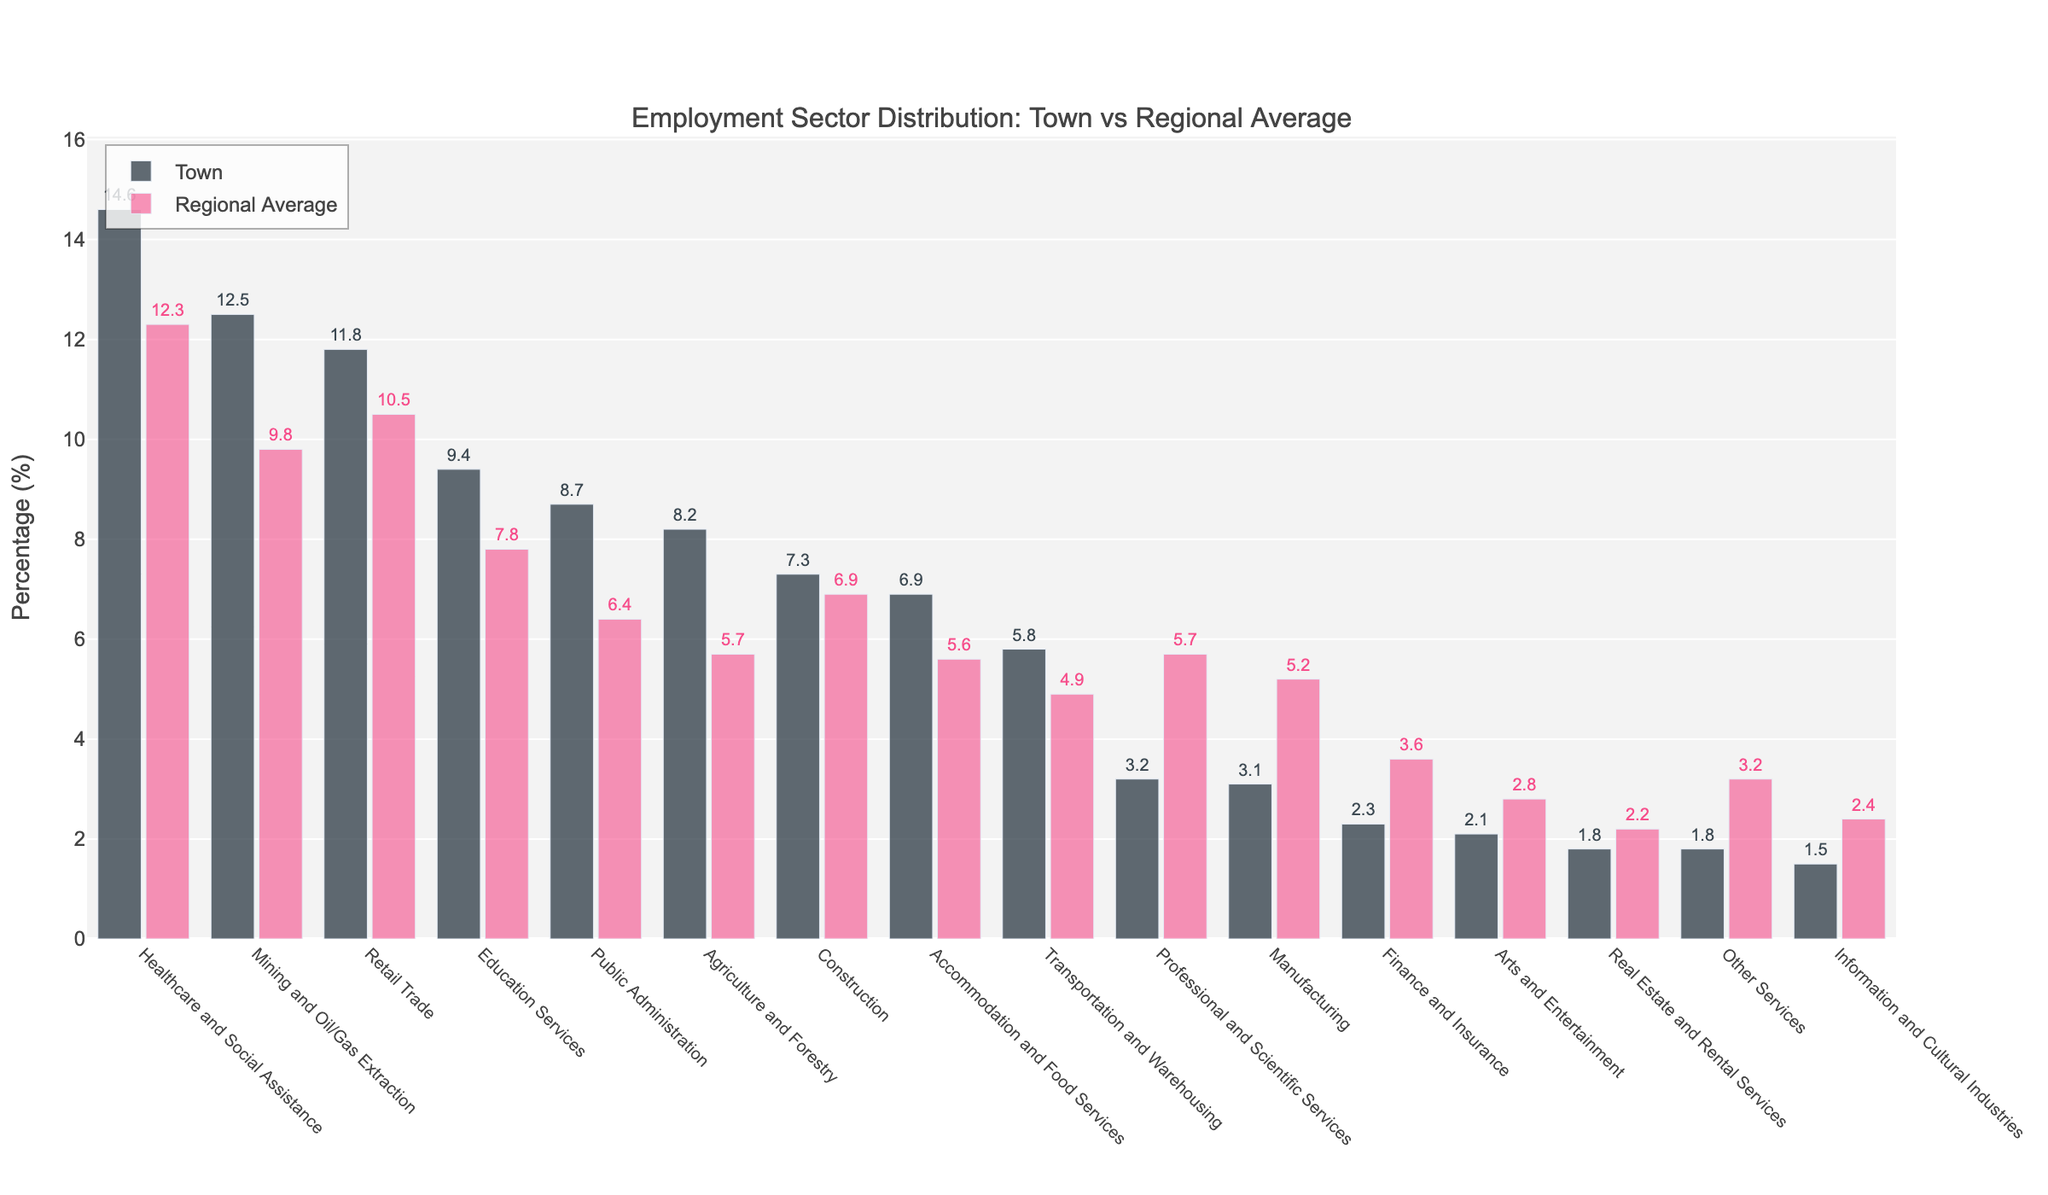How does the percentage of employment in Healthcare and Social Assistance compare between the town and the regional average? According to the figure, the bar representing Healthcare and Social Assistance is higher for the town than the regional average. Specifically, the town's percentage is 14.6% while the regional average is 12.3%. The town has a higher percentage in Healthcare and Social Assistance compared to the regional average.
Answer: The town has a higher percentage Which employment sector has the largest difference in percentage between the town and the regional average? To determine this, we observe the bars and compare the difference between the town and regional averages for each sector. The sector with the largest difference is Mining and Oil/Gas Extraction, with a town percentage of 12.5% compared to the regional average of 9.8%, giving a difference of 2.7%.
Answer: Mining and Oil/Gas Extraction What is the total percentage of employment in the Town for the sectors with a percentage greater than 10%? We add the percentages of the sectors with more than 10% in the town: Mining and Oil/Gas Extraction (12.5%), Retail Trade (11.8%), and Healthcare and Social Assistance (14.6%). The total is 12.5% + 11.8% + 14.6% = 38.9%.
Answer: 38.9% Which sector has a higher percentage in the town compared to regional averages but still has a relatively low overall percentage? By comparing the bars' heights, we can see that while Public Administration has a higher percentage in the town (8.7%) than the regional average (6.4%), it is still relatively lower compared to sectors like Healthcare and Social Assistance.
Answer: Public Administration How does employment in Education Services compare visually between the town and the regional average? Visually, the bar for Education Services is higher in the town compared to the regional average. The town’s bar goes up to 9.4% while the regional average bar is at 7.8%.
Answer: The town has a higher percentage For which sectors is the town’s employment percentage lower than the regional average? We identify sectors by comparing bar heights where the town's bar is shorter: Manufacturing (3.1% vs 5.2%), Professional and Scientific Services (3.2% vs 5.7%), Arts and Entertainment (2.1% vs 2.8%), Information and Cultural Industries (1.5% vs 2.4%), Finance and Insurance (2.3% vs 3.6%), Real Estate and Rental Services (1.8% vs 2.2%), Other Services (1.8% vs 3.2%).
Answer: Manufacturing, Professional and Scientific Services, Arts and Entertainment, Information and Cultural Industries, Finance and Insurance, Real Estate and Rental Services, Other Services What is the percentage difference between the sectors with the highest and lowest employment in the town? The highest percentage sector is Healthcare and Social Assistance (14.6%) and the lowest sectors are Real Estate and Rental Services and Other Services (both 1.8%). The difference is 14.6% - 1.8% = 12.8%.
Answer: 12.8% Which sector's employment is almost equal in the town and regional average? By comparing the bars, we find that Construction has percentages of 7.3% in the town and 6.9% in the region, making them nearly equal.
Answer: Construction 